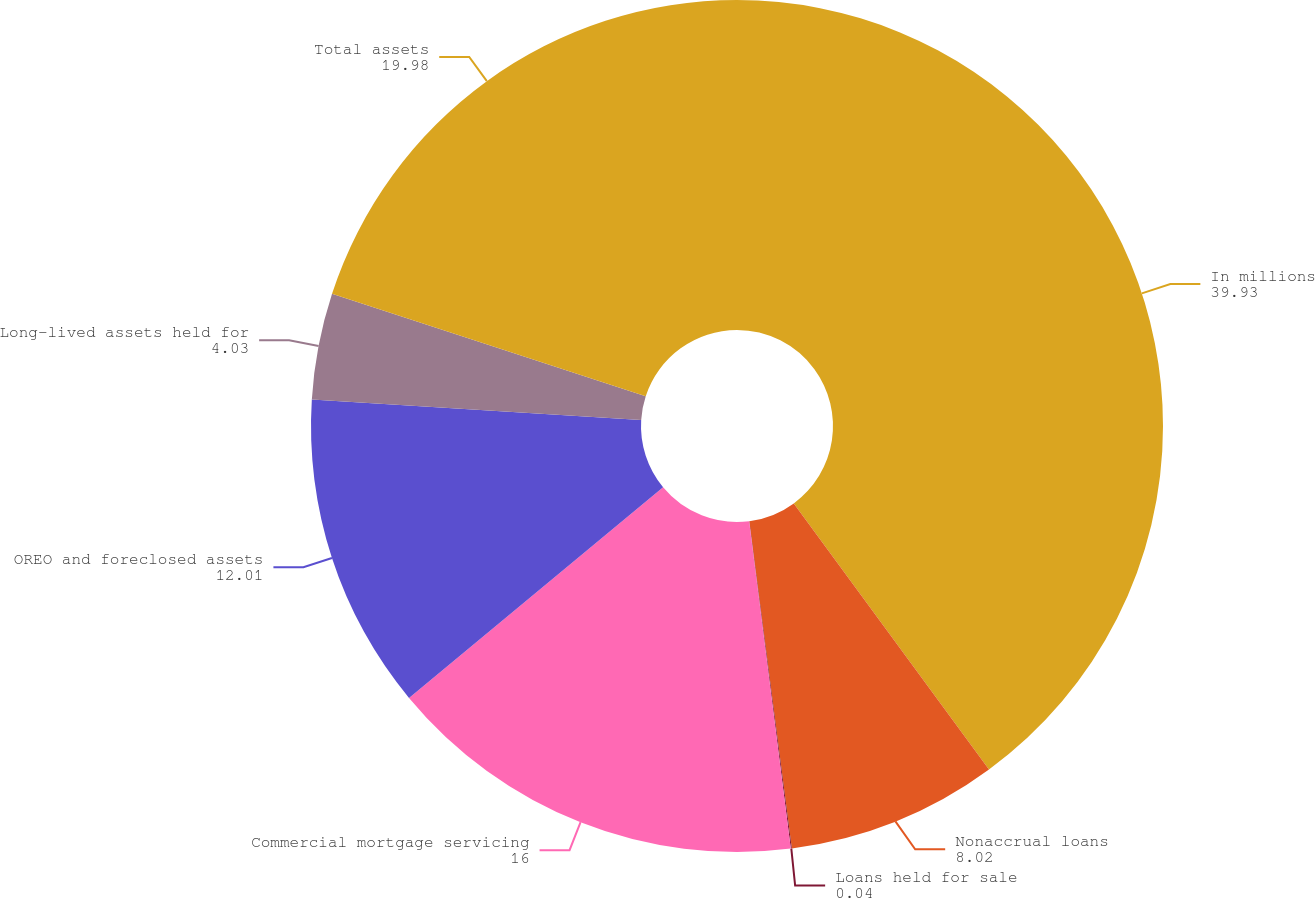<chart> <loc_0><loc_0><loc_500><loc_500><pie_chart><fcel>In millions<fcel>Nonaccrual loans<fcel>Loans held for sale<fcel>Commercial mortgage servicing<fcel>OREO and foreclosed assets<fcel>Long-lived assets held for<fcel>Total assets<nl><fcel>39.93%<fcel>8.02%<fcel>0.04%<fcel>16.0%<fcel>12.01%<fcel>4.03%<fcel>19.98%<nl></chart> 